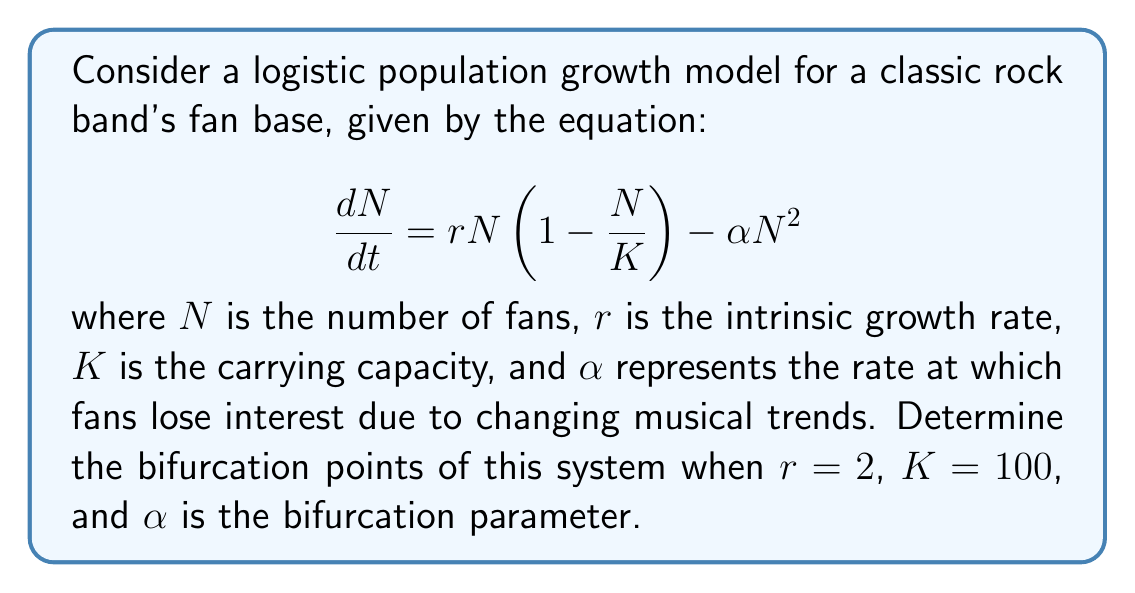Can you solve this math problem? To find the bifurcation points, we need to follow these steps:

1) First, find the equilibrium points by setting $\frac{dN}{dt} = 0$:

   $$0 = rN(1 - \frac{N}{K}) - \alpha N^2$$

2) Factor out $N$:

   $$0 = N(r(1 - \frac{N}{K}) - \alpha N)$$

3) Solve for $N$:
   
   $N = 0$ is one equilibrium point.
   For the other, solve:

   $$r(1 - \frac{N}{K}) - \alpha N = 0$$

4) Substitute the given values $r = 2$ and $K = 100$:

   $$2(1 - \frac{N}{100}) - \alpha N = 0$$

5) Simplify:

   $$2 - \frac{N}{50} - \alpha N = 0$$

6) Multiply by 50:

   $$100 - N - 50\alpha N = 0$$

7) Factor out $N$:

   $$100 - N(1 + 50\alpha) = 0$$

8) Solve for $N$:

   $$N = \frac{100}{1 + 50\alpha}$$

9) The bifurcation occurs when this non-zero equilibrium point coincides with the zero equilibrium point, i.e., when $N = 0$. This happens when the denominator approaches infinity:

   $$1 + 50\alpha \to \infty$$

   $$50\alpha \to \infty$$

   $$\alpha \to \infty$$

10) The other bifurcation point occurs when $N = K = 100$. Solve:

    $$100 = \frac{100}{1 + 50\alpha}$$

    $$1 + 50\alpha = 1$$

    $$50\alpha = 0$$

    $$\alpha = 0$$

Therefore, the bifurcation points are at $\alpha = 0$ and as $\alpha \to \infty$.
Answer: $\alpha = 0$ and $\alpha \to \infty$ 